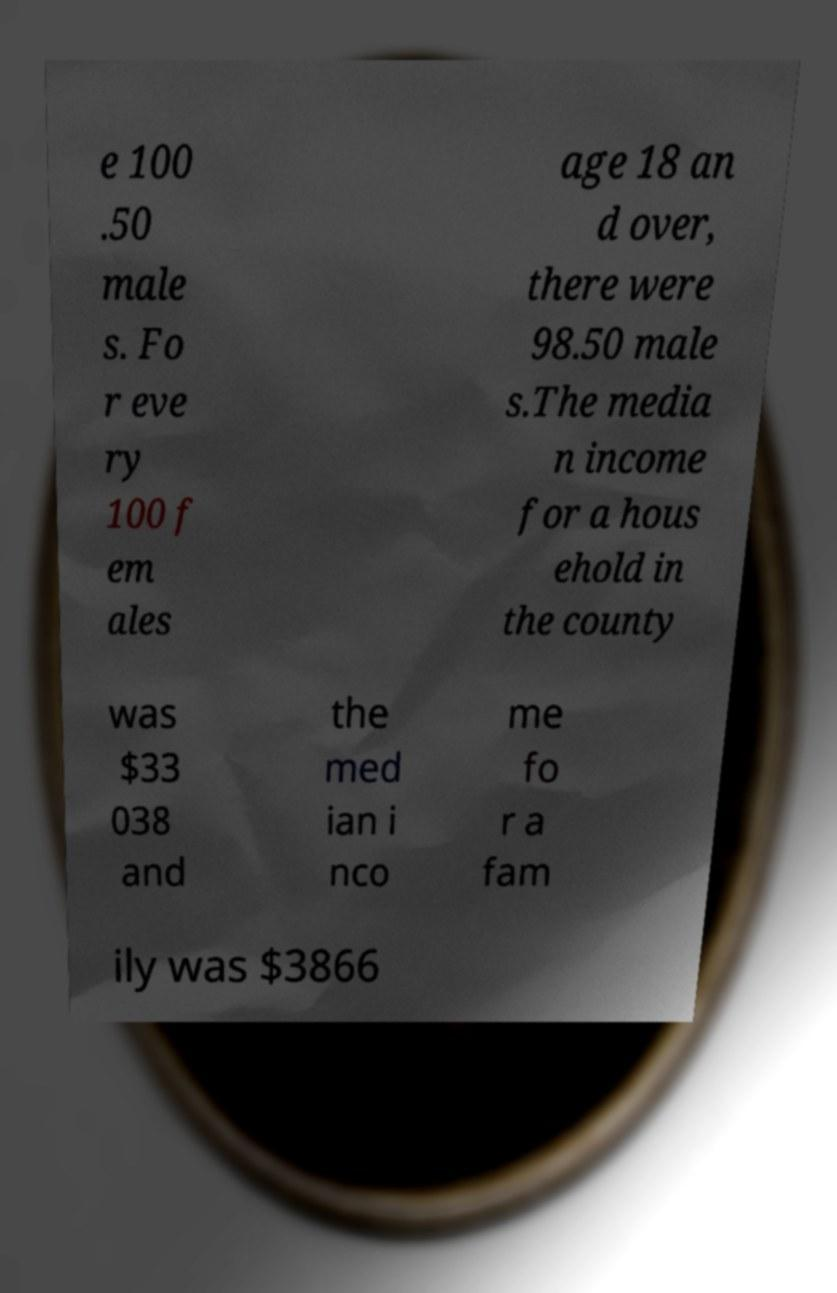There's text embedded in this image that I need extracted. Can you transcribe it verbatim? e 100 .50 male s. Fo r eve ry 100 f em ales age 18 an d over, there were 98.50 male s.The media n income for a hous ehold in the county was $33 038 and the med ian i nco me fo r a fam ily was $3866 